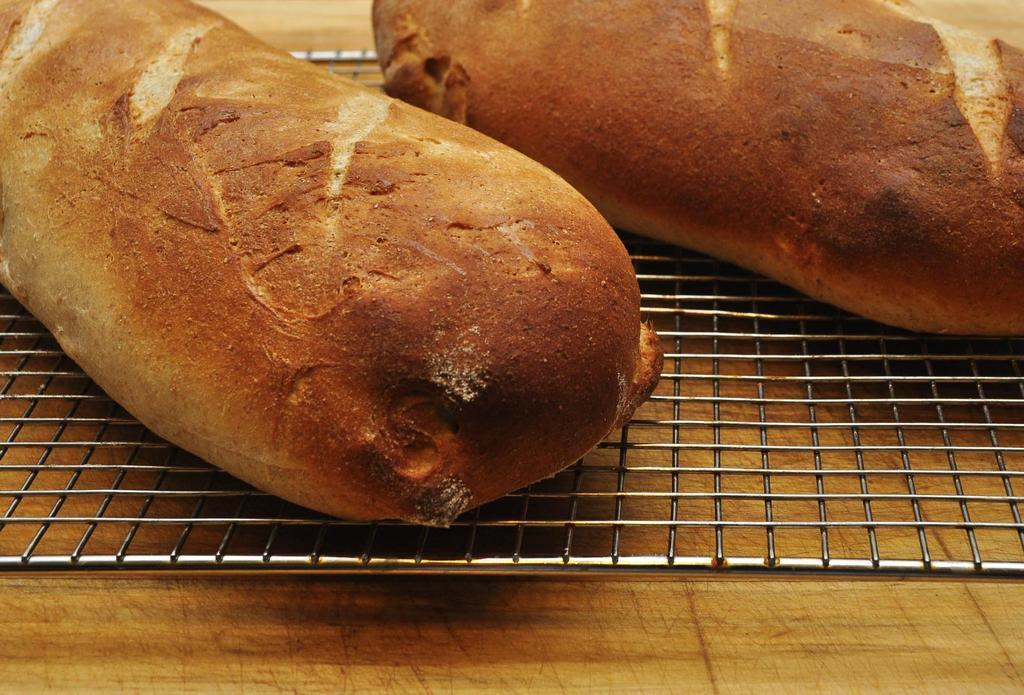What can be seen in the image related to food? There is food in the image. Can you describe the object on the table in the image? Unfortunately, the facts provided do not give enough information to describe the object on the table. How many legs can be seen supporting the flag in the image? There is no flag present in the image, so there are no legs supporting a flag. 